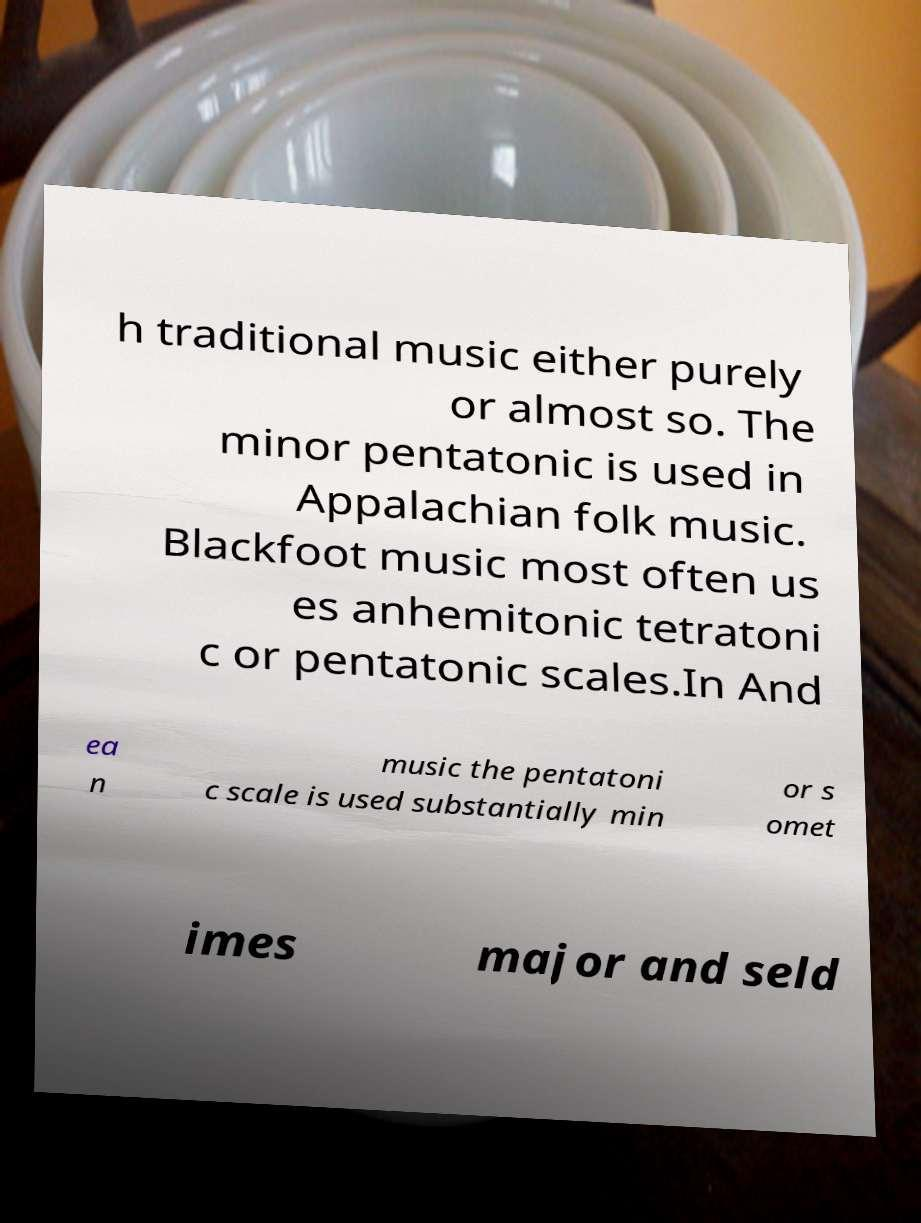Please read and relay the text visible in this image. What does it say? h traditional music either purely or almost so. The minor pentatonic is used in Appalachian folk music. Blackfoot music most often us es anhemitonic tetratoni c or pentatonic scales.In And ea n music the pentatoni c scale is used substantially min or s omet imes major and seld 